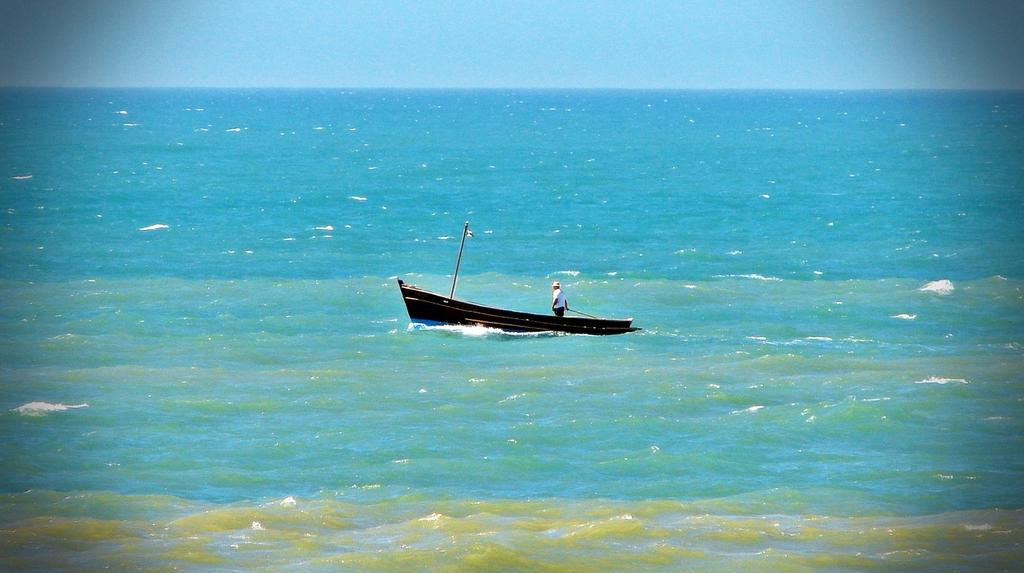What is the main element in the image? There is water in the image. What object is in the center of the image? There is a board in the center of the image. What is the person in the image doing? A person is standing on the board. What can be seen in the background of the image? The sky is visible in the background of the image. How would you describe the weather based on the image? The sky appears to be clear, suggesting good weather. How many bananas are on the board in the image? There are no bananas present in the image; it features a person standing on a board in the water. What type of furniture can be seen in the bedroom in the image? There is no bedroom or furniture present in the image; it shows a person standing on a board in the water with a clear sky in the background. 